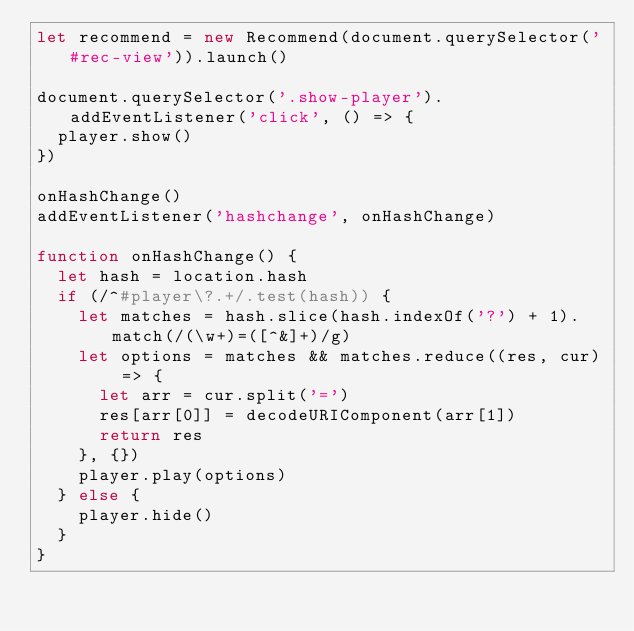Convert code to text. <code><loc_0><loc_0><loc_500><loc_500><_JavaScript_>let recommend = new Recommend(document.querySelector('#rec-view')).launch()

document.querySelector('.show-player').addEventListener('click', () => {
  player.show()
})

onHashChange()
addEventListener('hashchange', onHashChange)

function onHashChange() {
  let hash = location.hash
  if (/^#player\?.+/.test(hash)) {
    let matches = hash.slice(hash.indexOf('?') + 1).match(/(\w+)=([^&]+)/g)
    let options = matches && matches.reduce((res, cur) => {
      let arr = cur.split('=')
      res[arr[0]] = decodeURIComponent(arr[1])
      return res
    }, {})
    player.play(options)
  } else {
    player.hide()
  }
}</code> 